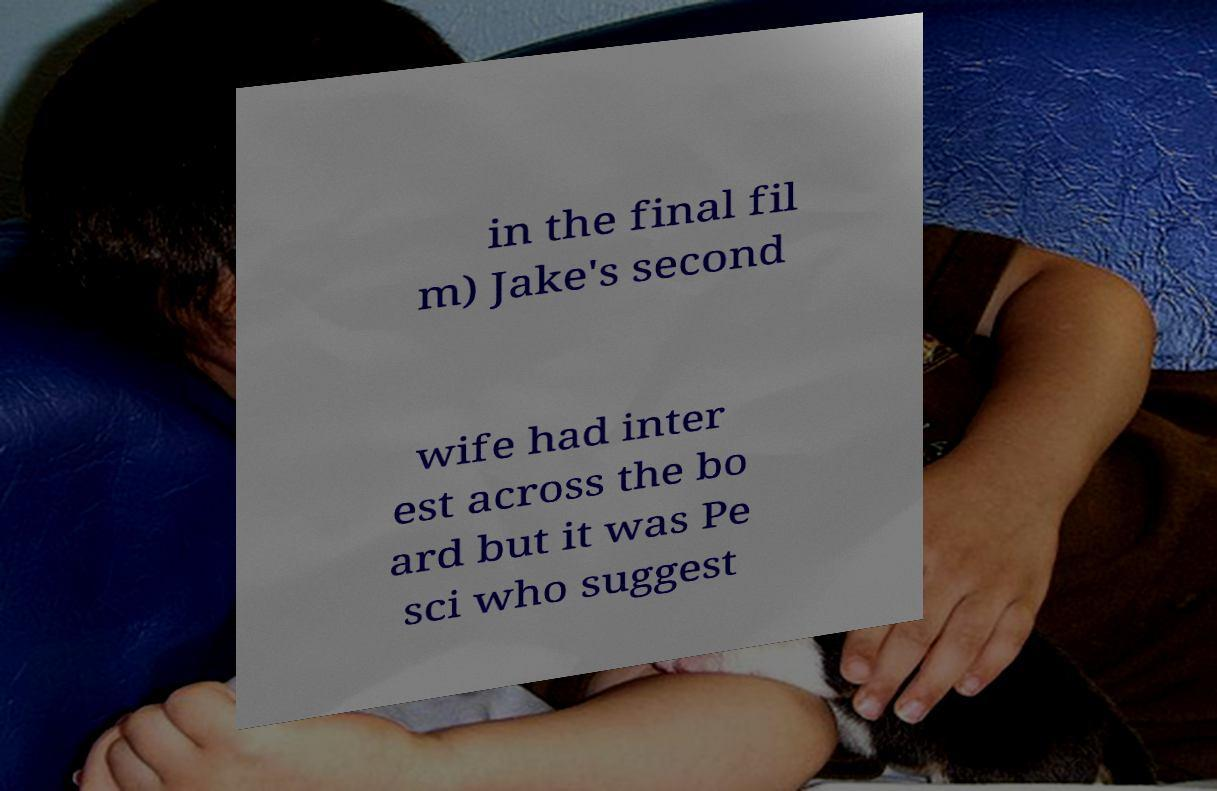For documentation purposes, I need the text within this image transcribed. Could you provide that? in the final fil m) Jake's second wife had inter est across the bo ard but it was Pe sci who suggest 